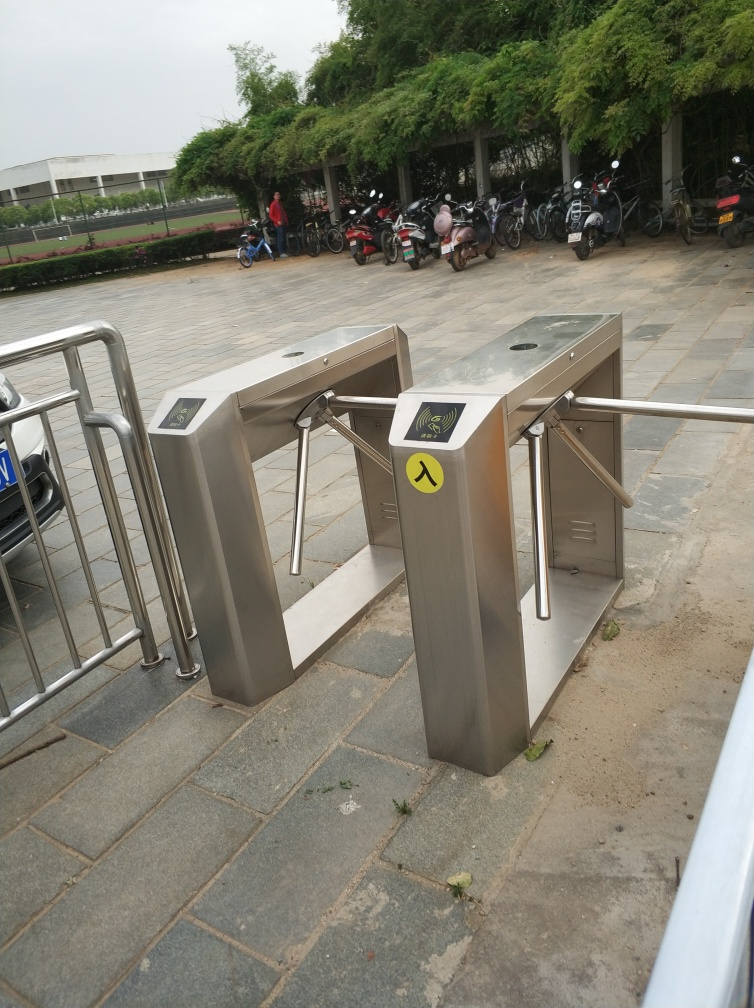What could improve the attractiveness of this public space? Enhancing the attractiveness of this public space could involve several steps such as regular maintenance to keep the area clean and tidy, including the removal of weeds growing between the paving stones. Additionally, adding directional signage can help visitors navigate, and incorporating elements like seating areas, artistic installations, or greenery can make the space more inviting and aesthetically pleasing. 